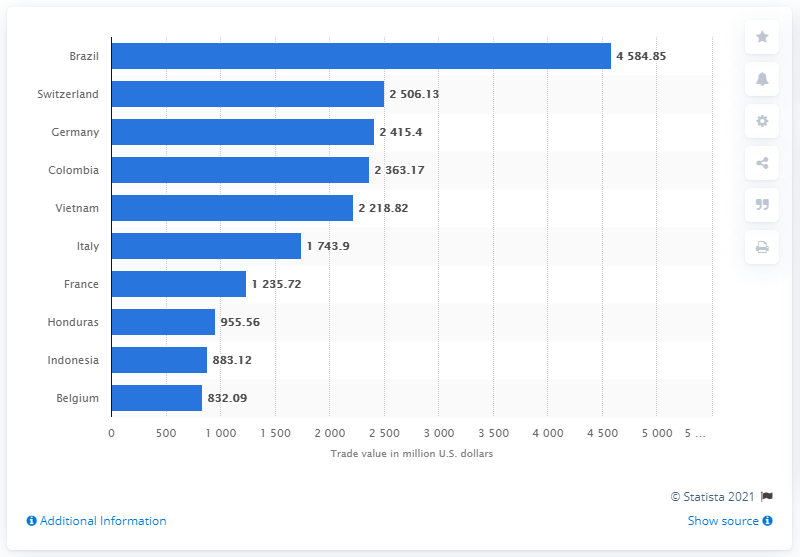Point out several critical features in this image. According to the provided information, the country that came in second in terms of trade value, with a value of approximately two and a half billion U.S. dollars, was Switzerland. Brazil is the world's leading coffee exporter. Brazil is the world's leading coffee exporter, accounting for the majority of global coffee exports. 